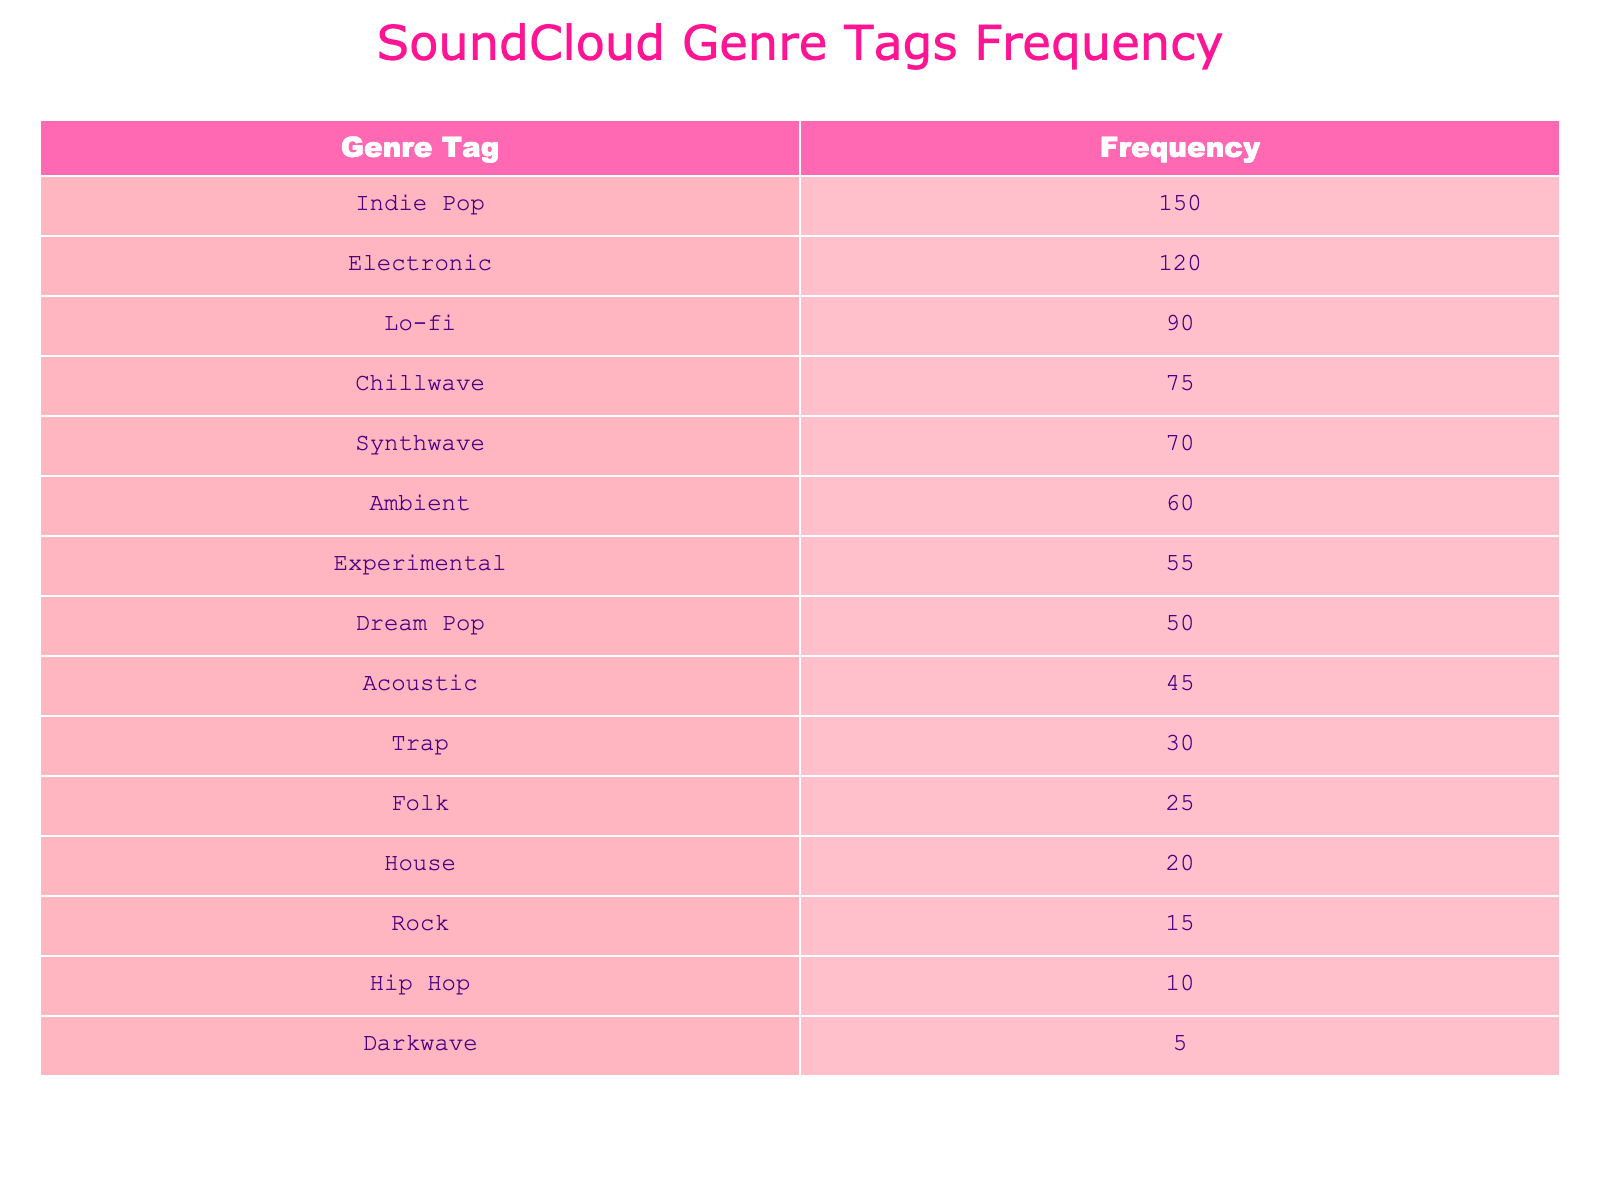What is the frequency of the genre tag "Indie Pop"? The table lists "Indie Pop" with a frequency of 150. This is a direct retrieval from the table.
Answer: 150 Which genre tag has the lowest frequency? By examining the frequency values in the table, "Darkwave" has the lowest frequency at 5. This is determined by comparing all the listed frequencies.
Answer: Darkwave What is the total frequency of the genres that include "Pop" in their names? The frequency of "Indie Pop" is 150, and "Dream Pop" is 50. Adding these two gives a total of 150 + 50 = 200.
Answer: 200 Is "Chillwave" more popular than "Lo-fi"? "Chillwave" has a frequency of 75, while "Lo-fi" has a frequency of 90. Since 75 is less than 90, the answer is no.
Answer: No What is the average frequency of the top three genres? The top three genres are "Indie Pop" (150), "Electronic" (120), and "Lo-fi" (90). To find the average, add these: 150 + 120 + 90 = 360, then divide by 3, which gives 360 / 3 = 120.
Answer: 120 How many genres have a frequency greater than 50? From the table, the genres with a frequency greater than 50 are "Indie Pop", "Electronic", "Lo-fi", "Chillwave", "Synthwave", "Ambient", and "Experimental", totaling 7 genres.
Answer: 7 What is the difference in frequency between "Trap" and "Folk"? "Trap" has a frequency of 30, while "Folk" has a frequency of 25. The difference is calculated as 30 - 25 = 5.
Answer: 5 Is "House" considered more popular than "Hip Hop"? "House" has a frequency of 20 and "Hip Hop" has a frequency of 10. Since 20 is greater than 10, the answer is yes.
Answer: Yes What is the sum of frequencies for genres listed under 60? The genres under 60 are "Ambient" (60), "Experimental" (55), "Dream Pop" (50), "Acoustic" (45), "Trap" (30), "Folk" (25), "House" (20), "Rock" (15), "Hip Hop" (10), and "Darkwave" (5). Their sum is 60 + 55 + 50 + 45 + 30 + 25 + 20 + 15 + 10 + 5 = 315.
Answer: 315 